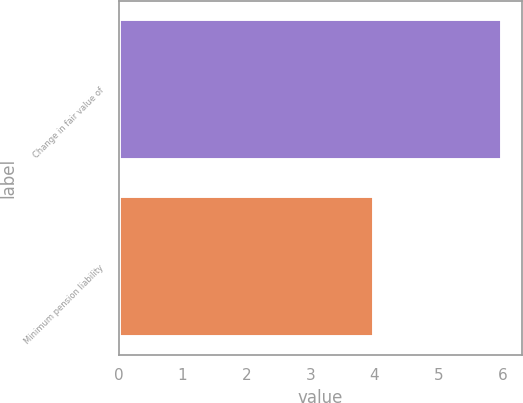Convert chart to OTSL. <chart><loc_0><loc_0><loc_500><loc_500><bar_chart><fcel>Change in fair value of<fcel>Minimum pension liability<nl><fcel>6<fcel>4<nl></chart> 